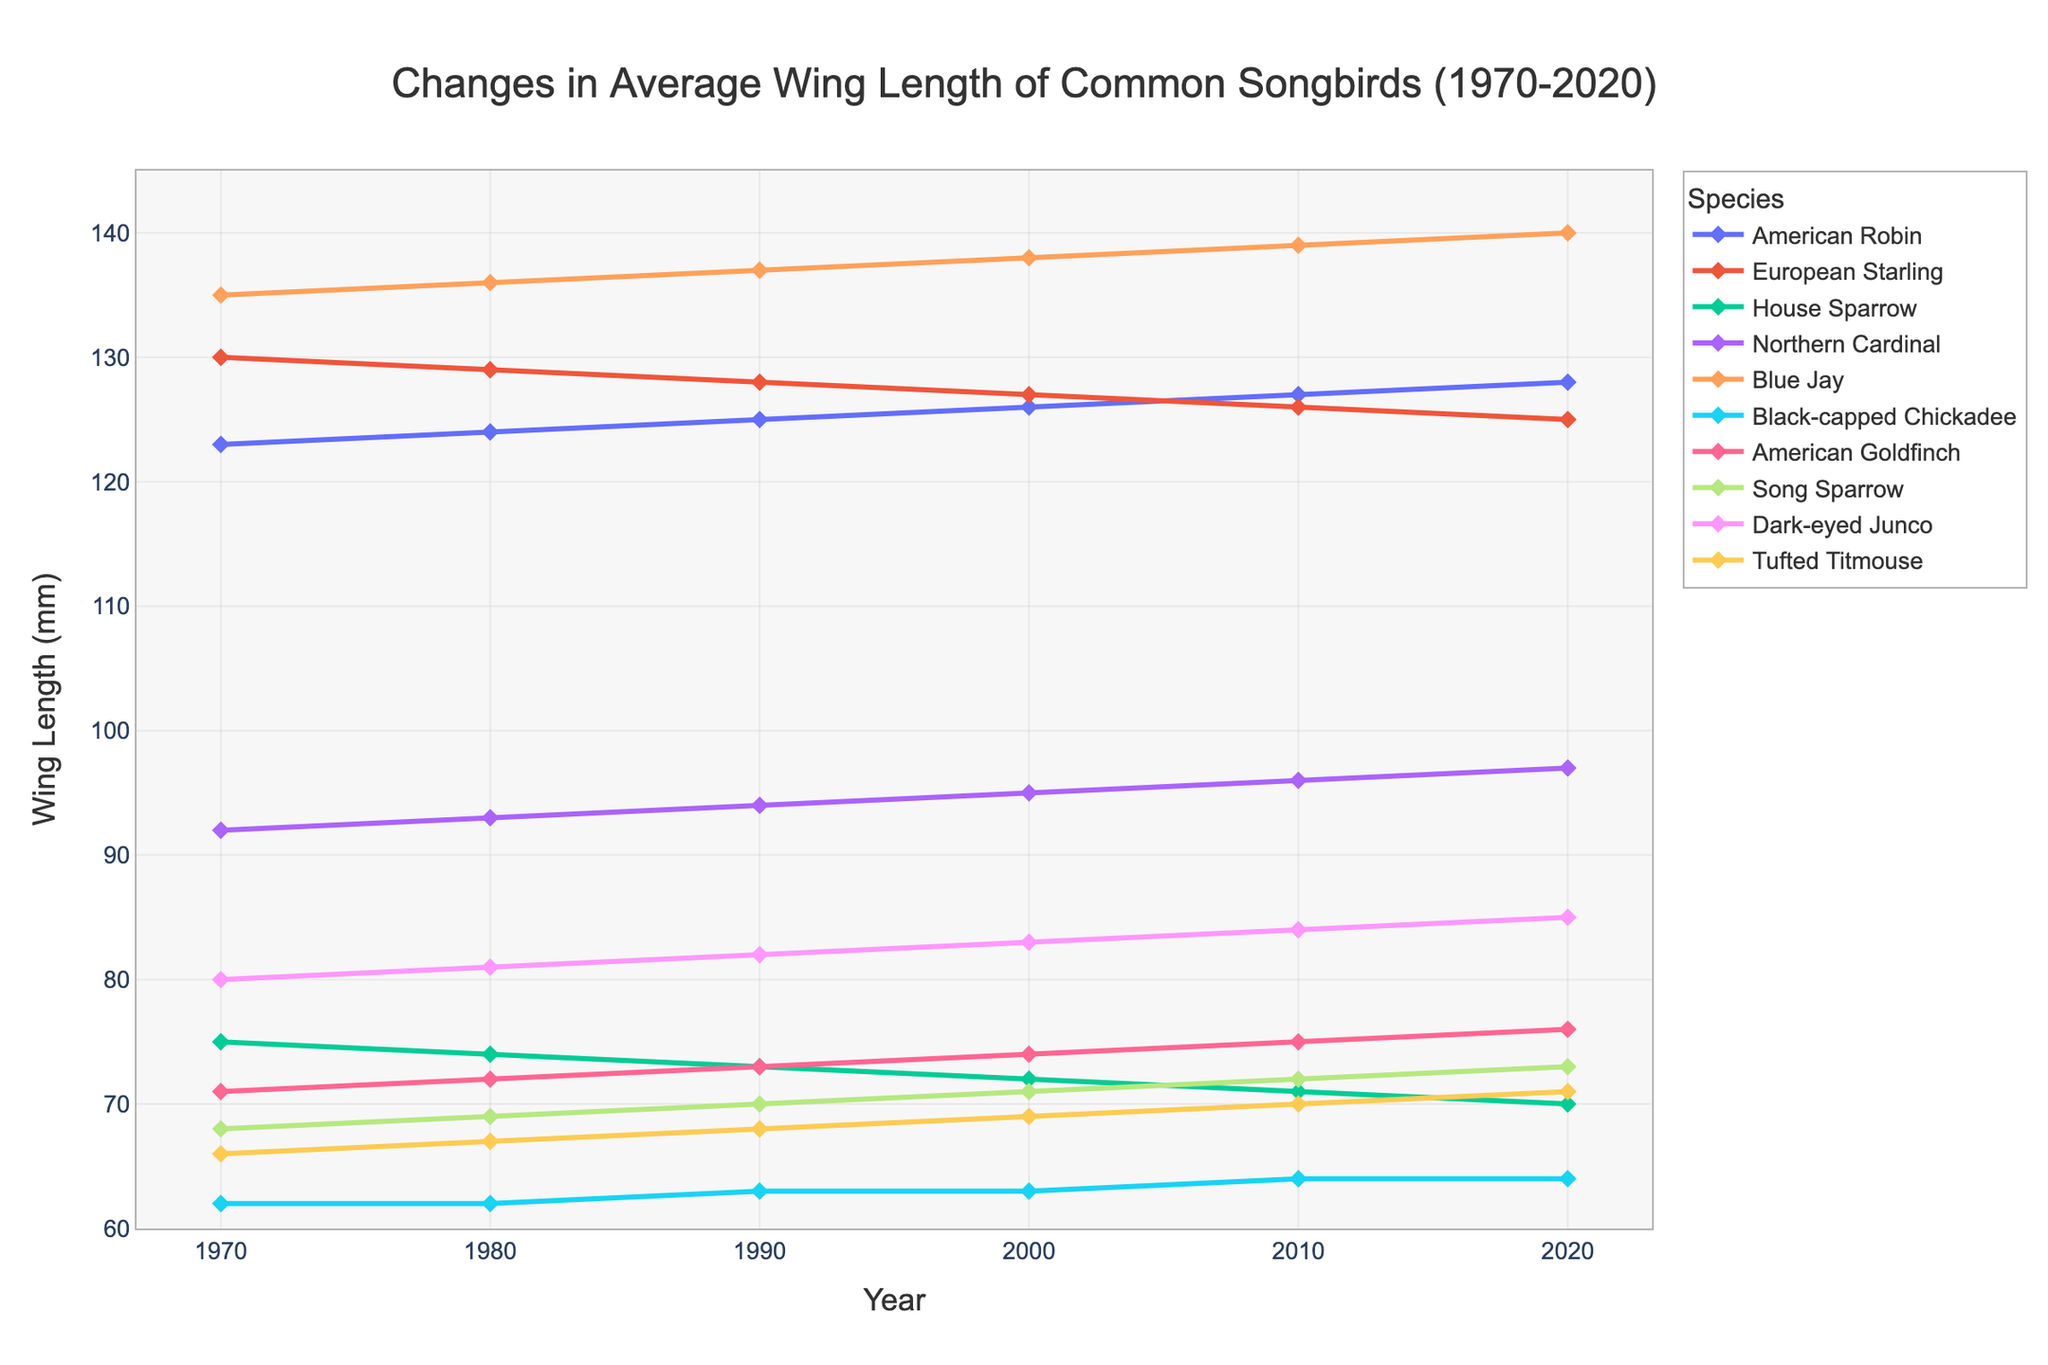What's the average wing length of the American Robin over the 50-year period? Add the wing length values for the American Robin (123, 124, 125, 126, 127, 128), which totals 753. Divide by the number of time points (6) to get the average: 753 / 6 = 125.5
Answer: 125.5 mm Which species shows a decreasing trend in wing length over 50 years? Look for a line that generally slopes downward from 1970 to 2020. The European Starling and House Sparrow show a consistent decrease in wing length over the period.
Answer: European Starling, House Sparrow Which species had the highest wing length in 2020? Focus on the endpoint of each line in the chart for the year 2020. The highest point corresponds to the Blue Jay, which has a wing length of 140 mm.
Answer: Blue Jay What's the difference in wing length between the Blue Jay and House Sparrow in 2020? Find the wing length for the Blue Jay (140 mm) and House Sparrow (70 mm) in 2020 and calculate the difference: 140 - 70 = 70 mm.
Answer: 70 mm Which species had the smallest change in wing length over the 50 years? Evaluate the difference between the starting and ending points of each line. The Black-capped Chickadee had the smallest change from 62 mm to 64 mm, which is a 2 mm change.
Answer: Black-capped Chickadee What is the average wing length of the species that increased over the 50-year period? Consider species with an upward trend: American Robin, Northern Cardinal, Blue Jay, Black-capped Chickadee, American Goldfinch, Song Sparrow, Dark-eyed Junco, Tufted Titmouse. Calculate their average ending wing lengths in 2020: (128+97+140+64+76+73+85+71)/8 = 84.25 mm
Answer: 84.25 mm Did any species show a constant wing length over the entire period? Look for a straight horizontal line across the chart. None of the species have a completely constant wing length across all years.
Answer: No 